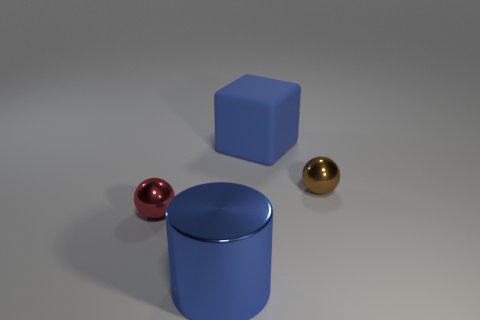How many other things are the same size as the blue cylinder?
Your answer should be very brief. 1. The big cylinder is what color?
Offer a very short reply. Blue. How many metal things are cyan spheres or red objects?
Provide a succinct answer. 1. Is there anything else that is made of the same material as the big blue block?
Give a very brief answer. No. There is a ball on the left side of the thing behind the tiny thing that is to the right of the rubber thing; what size is it?
Offer a very short reply. Small. There is a shiny object that is behind the blue metal object and on the left side of the big cube; what is its size?
Offer a very short reply. Small. There is a ball left of the brown shiny thing; does it have the same color as the big shiny thing in front of the brown sphere?
Offer a terse response. No. There is a tiny red thing; what number of small red spheres are behind it?
Give a very brief answer. 0. Are there any small shiny things that are in front of the tiny metallic ball behind the small ball left of the small brown metallic thing?
Make the answer very short. Yes. What number of other blue shiny cylinders are the same size as the cylinder?
Your answer should be compact. 0. 